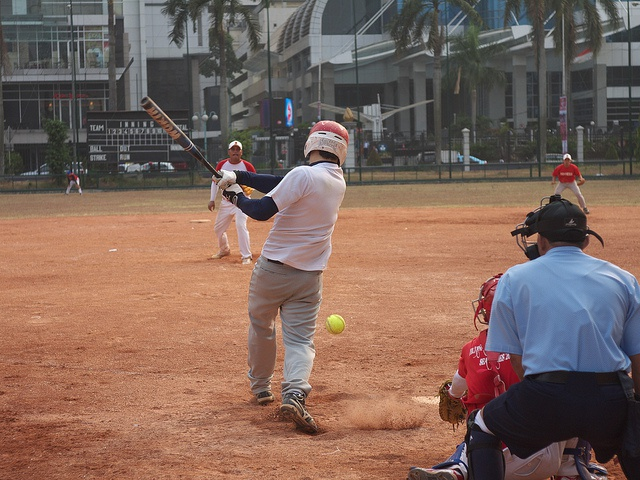Describe the objects in this image and their specific colors. I can see people in gray and black tones, people in gray, darkgray, and black tones, people in gray, maroon, brown, and black tones, people in gray, darkgray, black, brown, and lightgray tones, and baseball bat in gray, black, and maroon tones in this image. 